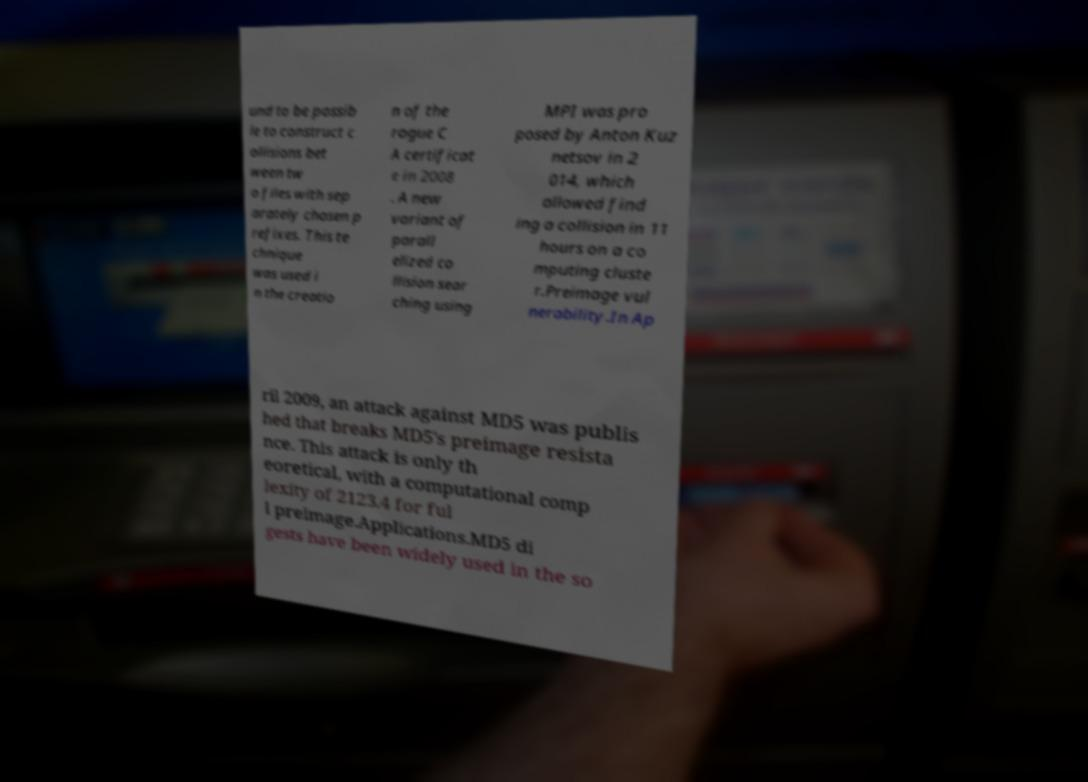Please identify and transcribe the text found in this image. und to be possib le to construct c ollisions bet ween tw o files with sep arately chosen p refixes. This te chnique was used i n the creatio n of the rogue C A certificat e in 2008 . A new variant of parall elized co llision sear ching using MPI was pro posed by Anton Kuz netsov in 2 014, which allowed find ing a collision in 11 hours on a co mputing cluste r.Preimage vul nerability.In Ap ril 2009, an attack against MD5 was publis hed that breaks MD5's preimage resista nce. This attack is only th eoretical, with a computational comp lexity of 2123.4 for ful l preimage.Applications.MD5 di gests have been widely used in the so 